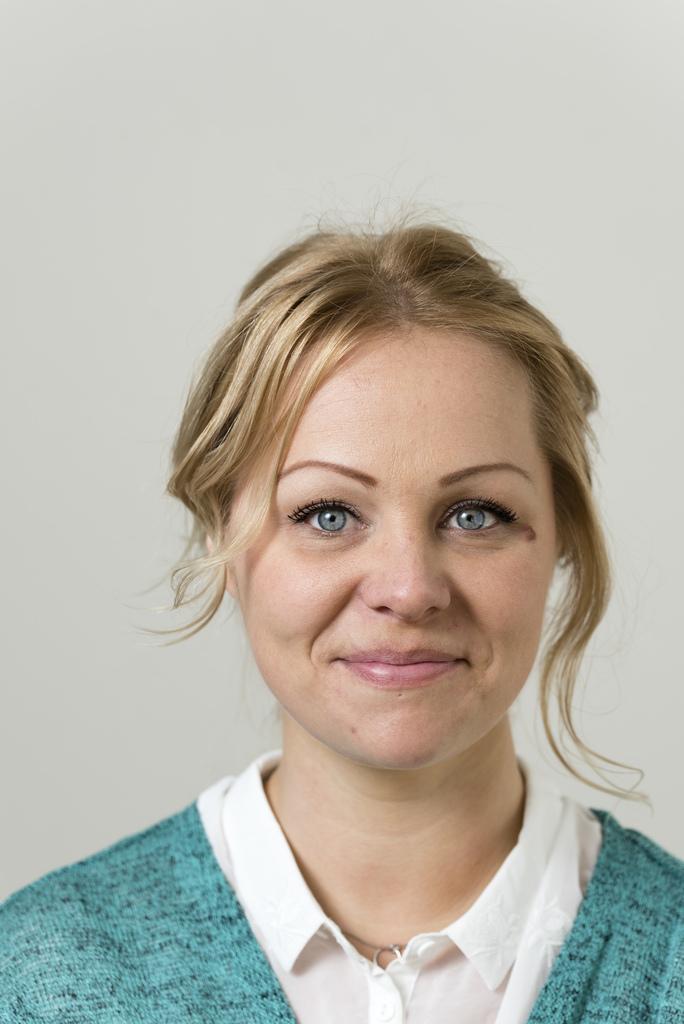Can you describe this image briefly? In the center of the image we can see a lady. She is smiling. In the background there is a wall. 